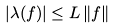Convert formula to latex. <formula><loc_0><loc_0><loc_500><loc_500>| \lambda ( f ) | \leq L \, \| f \|</formula> 